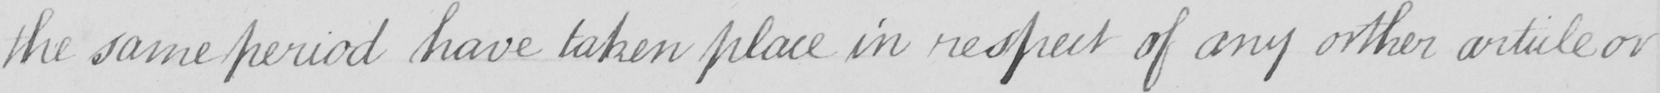Please provide the text content of this handwritten line. the same period have taken place in respect of any orther article or 